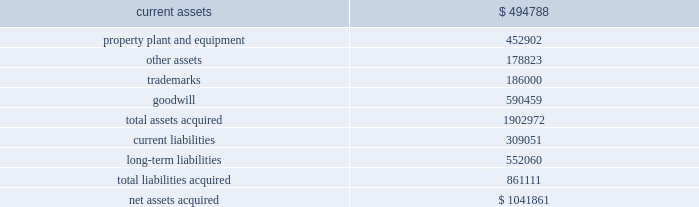Mondavi produces , markets and sells premium , super-premium and fine california wines under the woodbridge by robert mondavi , robert mondavi private selection and robert mondavi winery brand names .
Woodbridge and robert mondavi private selection are the leading premium and super-premium wine brands by volume , respectively , in the united states .
The acquisition of robert mondavi supports the company 2019s strategy of strengthening the breadth of its portfolio across price segments to capitalize on the overall growth in the pre- mium , super-premium and fine wine categories .
The company believes that the acquired robert mondavi brand names have strong brand recognition globally .
The vast majority of robert mondavi 2019s sales are generated in the united states .
The company intends to leverage the robert mondavi brands in the united states through its selling , marketing and distribution infrastructure .
The company also intends to further expand distribution for the robert mondavi brands in europe through its constellation europe infrastructure .
The company and robert mondavi have complementary busi- nesses that share a common growth orientation and operating philosophy .
The robert mondavi acquisition provides the company with a greater presence in the fine wine sector within the united states and the ability to capitalize on the broader geographic distribution in strategic international markets .
The robert mondavi acquisition supports the company 2019s strategy of growth and breadth across categories and geographies , and strengthens its competitive position in its core markets .
In par- ticular , the company believes there are growth opportunities for premium , super-premium and fine wines in the united kingdom , united states and other wine markets .
Total consid- eration paid in cash to the robert mondavi shareholders was $ 1030.7 million .
Additionally , the company expects to incur direct acquisition costs of $ 11.2 million .
The purchase price was financed with borrowings under the company 2019s 2004 credit agreement ( as defined in note 9 ) .
In accordance with the pur- chase method of accounting , the acquired net assets are recorded at fair value at the date of acquisition .
The purchase price was based primarily on the estimated future operating results of robert mondavi , including the factors described above , as well as an estimated benefit from operating cost synergies .
The results of operations of the robert mondavi business are reported in the constellation wines segment and have been included in the consolidated statement of income since the acquisition date .
The table summarizes the estimated fair values of the assets acquired and liabilities assumed in the robert mondavi acquisition at the date of acquisition .
The company is in the process of obtaining third-party valuations of certain assets and liabilities , and refining its restructuring plan which is under development and will be finalized during the company 2019s year ending february 28 , 2006 ( see note19 ) .
Accordingly , the allocation of the purchase price is subject to refinement .
Estimated fair values at december 22 , 2004 , are as follows : {in thousands} .
The trademarks are not subject to amortization .
None of the goodwill is expected to be deductible for tax purposes .
In connection with the robert mondavi acquisition and robert mondavi 2019s previously disclosed intention to sell certain of its winery properties and related assets , and other vineyard prop- erties , the company has classified certain assets as held for sale as of february 28 , 2005 .
The company expects to sell these assets during the year ended february 28 , 2006 , for net pro- ceeds of approximately $ 150 million to $ 175 million .
No gain or loss is expected to be recognized upon the sale of these assets .
Hardy acquisition 2013 on march 27 , 2003 , the company acquired control of brl hardy limited , now known as hardy wine company limited ( 201chardy 201d ) , and on april 9 , 2003 , the company completed its acquisition of all of hardy 2019s outstanding capital stock .
As a result of the acquisition of hardy , the company also acquired the remaining 50% ( 50 % ) ownership of pacific wine partners llc ( 201cpwp 201d ) , the joint venture the company established with hardy in july 2001 .
The acquisition of hardy along with the remaining interest in pwp is referred to together as the 201chardy acquisition . 201d through this acquisition , the company acquired one of australia 2019s largest wine producers with interests in winer- ies and vineyards in most of australia 2019s major wine regions as well as new zealand and the united states and hardy 2019s market- ing and sales operations in the united kingdom .
Total consideration paid in cash and class a common stock to the hardy shareholders was $ 1137.4 million .
Additionally , the company recorded direct acquisition costs of $ 17.2 million .
The acquisition date for accounting purposes is march 27 , 2003 .
The company has recorded a $ 1.6 million reduction in the purchase price to reflect imputed interest between the accounting acquisition date and the final payment of consider- ation .
This charge is included as interest expense in the consolidated statement of income for the year ended february 29 , 2004 .
The cash portion of the purchase price paid to the hardy shareholders and optionholders ( $ 1060.2 mil- lion ) was financed with $ 660.2 million of borrowings under the company 2019s then existing credit agreement and $ 400.0 million .
Of the two acquisitions , was the purchase price of the hardy acquisition greater than the mondavi acquisition? 
Computations: (1137.4 > 1030.7)
Answer: yes. 